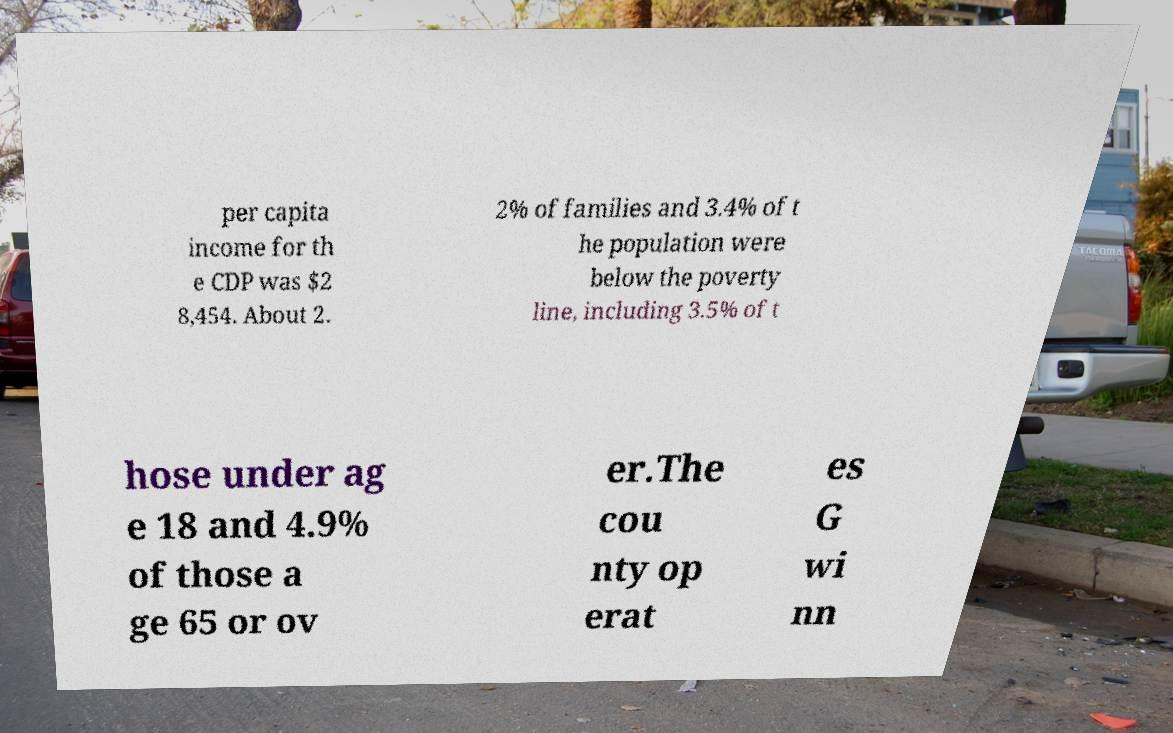Please read and relay the text visible in this image. What does it say? per capita income for th e CDP was $2 8,454. About 2. 2% of families and 3.4% of t he population were below the poverty line, including 3.5% of t hose under ag e 18 and 4.9% of those a ge 65 or ov er.The cou nty op erat es G wi nn 